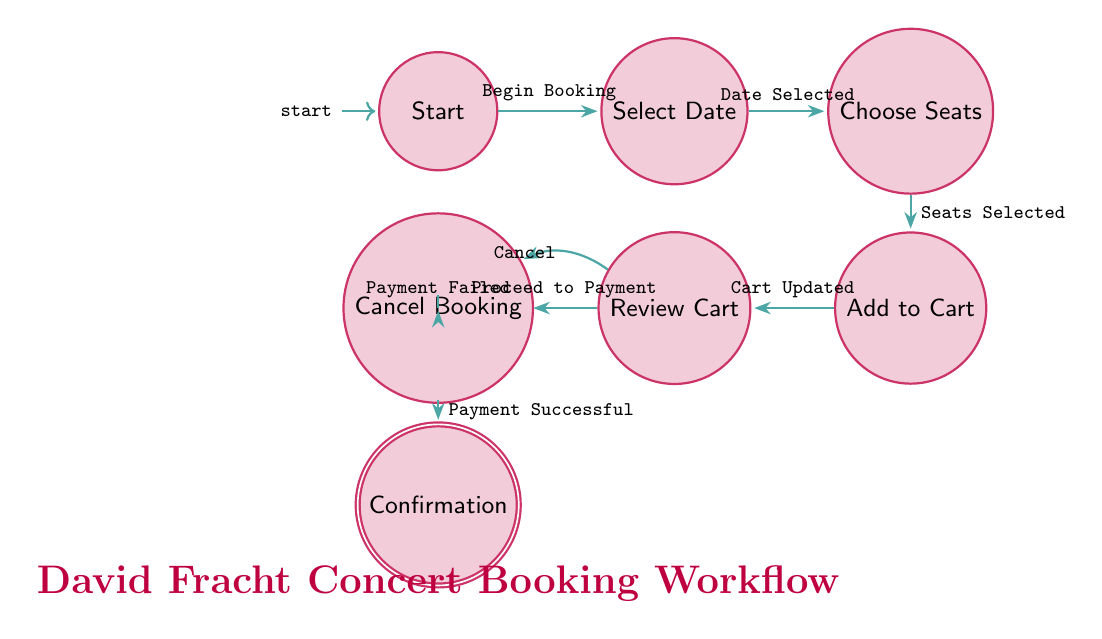What is the starting state of the concert booking workflow? The initial state is labeled "Start" as indicated in the diagram. This is where the user begins the ticket booking process.
Answer: Start How many nodes are in the diagram? The diagram consists of eight nodes, including the start state, intermediate states, and the final state. Each state corresponds to a specific step in the ticket booking workflow.
Answer: Eight What is the transition trigger from "Add to Cart" to "Review Cart"? The transition trigger is labeled "Cart Updated," which indicates that the user adds seats to their cart and proceeds to review their selections.
Answer: Cart Updated Which state comes after "Make Payment" if the payment is successful? The state that follows "Make Payment" is "Confirmation," as it signifies the successful processing of the payment and the user receiving booking confirmation.
Answer: Confirmation What options does the user have when in the "Review Cart" state? The options available in the "Review Cart" state are either to "Proceed to Payment" or to "Cancel," allowing the user to proceed with the purchase or to cancel the process.
Answer: Proceed to Payment or Cancel If the user cancels the booking after selecting seats, which state do they return to? If the user cancels the booking after selecting seats, they would return to the "Cancel Booking" state, as indicated by the option available from multiple previous states including "Review Cart" and "Make Payment".
Answer: Cancel Booking What is the relationship between "Choose Seats" and "Add to Cart"? The relationship is a direct transition where the trigger "Seats Selected" allows the user to move from "Choose Seats" to "Add to Cart" after finalizing their seat selections.
Answer: Seats Selected How many total transitions are present in the diagram? There are a total of eight transitions depicted in the diagram, representing various actions that lead the user through different states in the ticket booking workflow.
Answer: Eight 